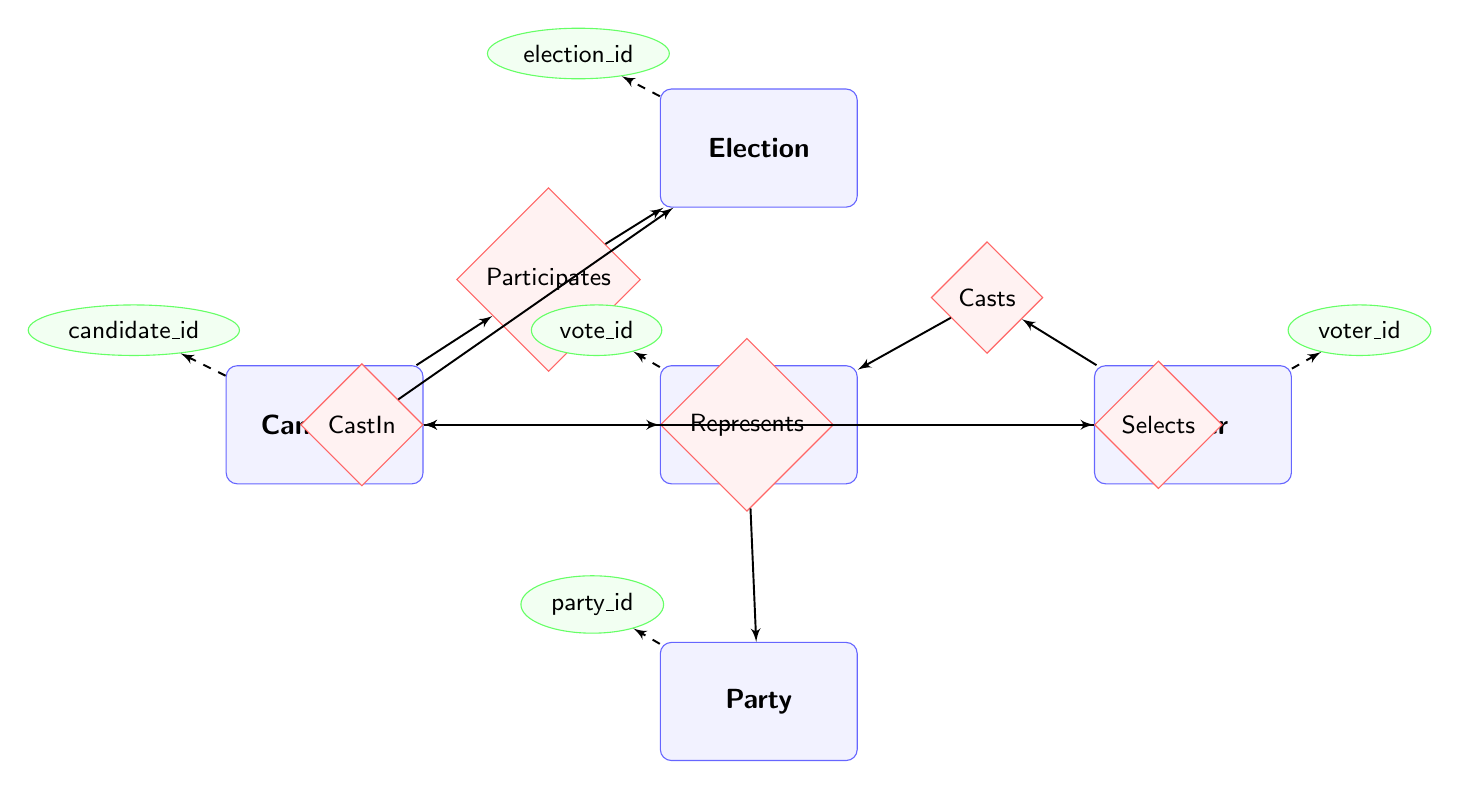What is the type of the entity "Election"? In the diagram, entities are represented by rectangles. The entity "Election" is labeled, and upon examining the attributes associated with it, we can conclude that its type is simply "Election."
Answer: Election How many relationships are present in the diagram? The diagram features relationships represented by diamonds which link the entities together. Counting the diamonds shows that there are five distinct relationships, namely "Participates," "Represents," "Casts," "CastIn," and "Selects."
Answer: 5 Which candidate participates in elections? To determine this, we look at the "Participates" relationship, which connects the "Candidate" entity to the "Election" entity. Thus, any candidate in the diagram is involved in elections through this relationship.
Answer: Candidate Which entity is connected to "Vote" through "Casts"? The "Casts" relationship specifically connects the "Voter" entity to the "Vote" entity, establishing that voters are the ones casting votes.
Answer: Voter If a voter casts a vote, what is the relationship that links them both? The relationship that links a voter who casts a vote is named "Casts." This diamond connects the "Voter" entity to the "Vote" entity.
Answer: Casts How does a candidate represent their party? The relationship "Represents" connects the "Candidate" entity to the "Party" entity. This indicates that candidates are tied to parties, showing how candidates represent the parties in elections.
Answer: Represents What are the two entities that participate in a voting process? In the voting process, the entities involved are the "Voter," who casts the vote, and the "Vote" which is the act of casting itself. They are connected via the "Casts" relationship.
Answer: Voter, Vote What is the relationship between "Vote" and "Election"? The relationship that links these two entities is "CastIn," which indicates that votes are cast within the context of an election.
Answer: CastIn What attribute is specific to the "Party" entity? The "Party" entity has several attributes, but one specific to it is "founded_date," which indicates when the party was established.
Answer: founded_date 